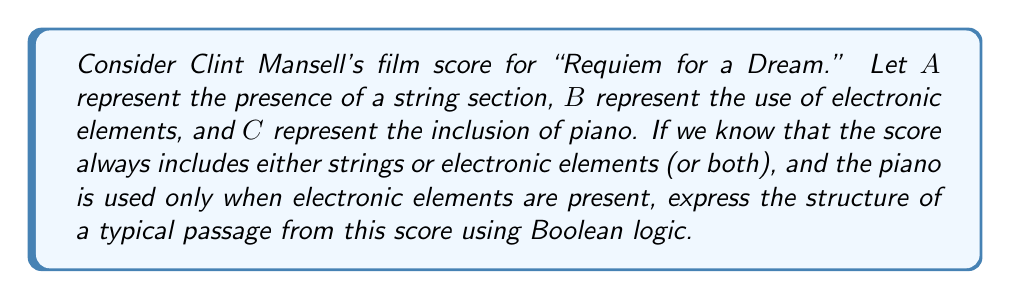Show me your answer to this math problem. Let's approach this step-by-step:

1) First, we need to express that the score always includes either strings or electronic elements (or both):
   $$(A \lor B)$$

2) Next, we need to represent that the piano is used only when electronic elements are present. This can be expressed as:
   $$(C \rightarrow B)$$

3) We can combine these conditions using the AND operator ($\land$):
   $$(A \lor B) \land (C \rightarrow B)$$

4) We can expand this using the definition of implication:
   $$(A \lor B) \land (\lnot C \lor B)$$

5) This expression represents the structure of a typical passage in Mansell's score for "Requiem for a Dream" using Boolean logic.

6) To simplify further, we can use the distributive law:
   $$((A \lor B) \land \lnot C) \lor ((A \lor B) \land B)$$

7) Simplify the right side using the absorption law $(X \land (X \lor Y) = X)$:
   $$((A \lor B) \land \lnot C) \lor B$$

This final expression represents the Boolean structure of the score, indicating that in any passage, we either have strings or electronic elements (or both) without piano, or we have electronic elements (which may or may not include strings or piano).
Answer: $((A \lor B) \land \lnot C) \lor B$ 